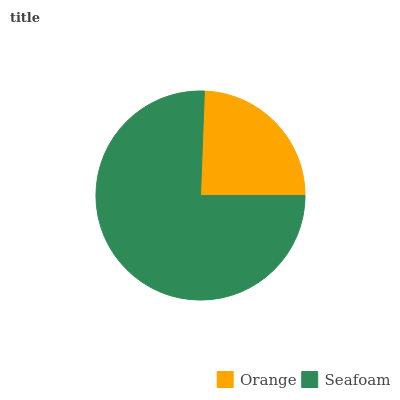Is Orange the minimum?
Answer yes or no. Yes. Is Seafoam the maximum?
Answer yes or no. Yes. Is Seafoam the minimum?
Answer yes or no. No. Is Seafoam greater than Orange?
Answer yes or no. Yes. Is Orange less than Seafoam?
Answer yes or no. Yes. Is Orange greater than Seafoam?
Answer yes or no. No. Is Seafoam less than Orange?
Answer yes or no. No. Is Seafoam the high median?
Answer yes or no. Yes. Is Orange the low median?
Answer yes or no. Yes. Is Orange the high median?
Answer yes or no. No. Is Seafoam the low median?
Answer yes or no. No. 